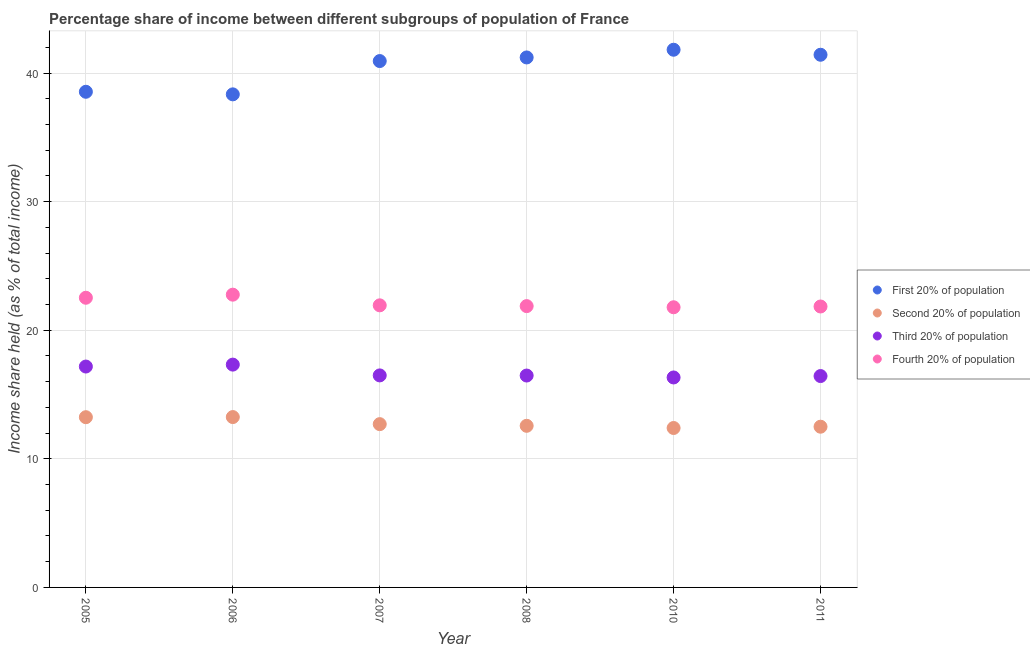What is the share of the income held by fourth 20% of the population in 2010?
Ensure brevity in your answer.  21.79. Across all years, what is the maximum share of the income held by third 20% of the population?
Offer a very short reply. 17.33. Across all years, what is the minimum share of the income held by third 20% of the population?
Your response must be concise. 16.33. In which year was the share of the income held by third 20% of the population maximum?
Your answer should be compact. 2006. In which year was the share of the income held by first 20% of the population minimum?
Keep it short and to the point. 2006. What is the total share of the income held by fourth 20% of the population in the graph?
Give a very brief answer. 132.76. What is the difference between the share of the income held by first 20% of the population in 2010 and that in 2011?
Make the answer very short. 0.39. What is the difference between the share of the income held by first 20% of the population in 2006 and the share of the income held by second 20% of the population in 2008?
Offer a terse response. 25.78. What is the average share of the income held by fourth 20% of the population per year?
Your answer should be compact. 22.13. In the year 2005, what is the difference between the share of the income held by second 20% of the population and share of the income held by fourth 20% of the population?
Your answer should be compact. -9.29. In how many years, is the share of the income held by third 20% of the population greater than 28 %?
Your answer should be very brief. 0. What is the ratio of the share of the income held by fourth 20% of the population in 2005 to that in 2006?
Your response must be concise. 0.99. Is the difference between the share of the income held by first 20% of the population in 2010 and 2011 greater than the difference between the share of the income held by fourth 20% of the population in 2010 and 2011?
Provide a short and direct response. Yes. What is the difference between the highest and the second highest share of the income held by first 20% of the population?
Offer a very short reply. 0.39. What is the difference between the highest and the lowest share of the income held by third 20% of the population?
Ensure brevity in your answer.  1. In how many years, is the share of the income held by third 20% of the population greater than the average share of the income held by third 20% of the population taken over all years?
Ensure brevity in your answer.  2. Is it the case that in every year, the sum of the share of the income held by third 20% of the population and share of the income held by second 20% of the population is greater than the sum of share of the income held by first 20% of the population and share of the income held by fourth 20% of the population?
Make the answer very short. No. Does the share of the income held by second 20% of the population monotonically increase over the years?
Make the answer very short. No. Is the share of the income held by second 20% of the population strictly less than the share of the income held by third 20% of the population over the years?
Make the answer very short. Yes. How many dotlines are there?
Offer a very short reply. 4. How many years are there in the graph?
Provide a short and direct response. 6. Does the graph contain grids?
Offer a very short reply. Yes. How many legend labels are there?
Provide a short and direct response. 4. How are the legend labels stacked?
Your answer should be compact. Vertical. What is the title of the graph?
Provide a succinct answer. Percentage share of income between different subgroups of population of France. What is the label or title of the X-axis?
Ensure brevity in your answer.  Year. What is the label or title of the Y-axis?
Make the answer very short. Income share held (as % of total income). What is the Income share held (as % of total income) in First 20% of population in 2005?
Offer a terse response. 38.55. What is the Income share held (as % of total income) in Second 20% of population in 2005?
Offer a terse response. 13.24. What is the Income share held (as % of total income) of Third 20% of population in 2005?
Your response must be concise. 17.18. What is the Income share held (as % of total income) in Fourth 20% of population in 2005?
Your answer should be very brief. 22.53. What is the Income share held (as % of total income) of First 20% of population in 2006?
Provide a succinct answer. 38.35. What is the Income share held (as % of total income) in Second 20% of population in 2006?
Offer a terse response. 13.25. What is the Income share held (as % of total income) in Third 20% of population in 2006?
Make the answer very short. 17.33. What is the Income share held (as % of total income) of Fourth 20% of population in 2006?
Provide a short and direct response. 22.77. What is the Income share held (as % of total income) in First 20% of population in 2007?
Make the answer very short. 40.94. What is the Income share held (as % of total income) in Third 20% of population in 2007?
Make the answer very short. 16.49. What is the Income share held (as % of total income) of Fourth 20% of population in 2007?
Your answer should be very brief. 21.94. What is the Income share held (as % of total income) of First 20% of population in 2008?
Provide a succinct answer. 41.22. What is the Income share held (as % of total income) in Second 20% of population in 2008?
Your response must be concise. 12.57. What is the Income share held (as % of total income) in Third 20% of population in 2008?
Your answer should be very brief. 16.48. What is the Income share held (as % of total income) in Fourth 20% of population in 2008?
Your response must be concise. 21.88. What is the Income share held (as % of total income) of First 20% of population in 2010?
Offer a very short reply. 41.82. What is the Income share held (as % of total income) of Second 20% of population in 2010?
Make the answer very short. 12.4. What is the Income share held (as % of total income) of Third 20% of population in 2010?
Make the answer very short. 16.33. What is the Income share held (as % of total income) in Fourth 20% of population in 2010?
Keep it short and to the point. 21.79. What is the Income share held (as % of total income) of First 20% of population in 2011?
Your answer should be very brief. 41.43. What is the Income share held (as % of total income) in Second 20% of population in 2011?
Provide a succinct answer. 12.5. What is the Income share held (as % of total income) in Third 20% of population in 2011?
Your answer should be compact. 16.44. What is the Income share held (as % of total income) in Fourth 20% of population in 2011?
Offer a very short reply. 21.85. Across all years, what is the maximum Income share held (as % of total income) in First 20% of population?
Ensure brevity in your answer.  41.82. Across all years, what is the maximum Income share held (as % of total income) of Second 20% of population?
Your answer should be very brief. 13.25. Across all years, what is the maximum Income share held (as % of total income) of Third 20% of population?
Ensure brevity in your answer.  17.33. Across all years, what is the maximum Income share held (as % of total income) in Fourth 20% of population?
Your answer should be compact. 22.77. Across all years, what is the minimum Income share held (as % of total income) of First 20% of population?
Your response must be concise. 38.35. Across all years, what is the minimum Income share held (as % of total income) in Second 20% of population?
Your response must be concise. 12.4. Across all years, what is the minimum Income share held (as % of total income) of Third 20% of population?
Provide a short and direct response. 16.33. Across all years, what is the minimum Income share held (as % of total income) in Fourth 20% of population?
Your answer should be very brief. 21.79. What is the total Income share held (as % of total income) in First 20% of population in the graph?
Your answer should be compact. 242.31. What is the total Income share held (as % of total income) in Second 20% of population in the graph?
Your answer should be compact. 76.66. What is the total Income share held (as % of total income) in Third 20% of population in the graph?
Keep it short and to the point. 100.25. What is the total Income share held (as % of total income) in Fourth 20% of population in the graph?
Offer a terse response. 132.76. What is the difference between the Income share held (as % of total income) in Second 20% of population in 2005 and that in 2006?
Give a very brief answer. -0.01. What is the difference between the Income share held (as % of total income) in Third 20% of population in 2005 and that in 2006?
Your answer should be very brief. -0.15. What is the difference between the Income share held (as % of total income) in Fourth 20% of population in 2005 and that in 2006?
Keep it short and to the point. -0.24. What is the difference between the Income share held (as % of total income) in First 20% of population in 2005 and that in 2007?
Make the answer very short. -2.39. What is the difference between the Income share held (as % of total income) of Second 20% of population in 2005 and that in 2007?
Your response must be concise. 0.54. What is the difference between the Income share held (as % of total income) of Third 20% of population in 2005 and that in 2007?
Keep it short and to the point. 0.69. What is the difference between the Income share held (as % of total income) in Fourth 20% of population in 2005 and that in 2007?
Your response must be concise. 0.59. What is the difference between the Income share held (as % of total income) in First 20% of population in 2005 and that in 2008?
Offer a very short reply. -2.67. What is the difference between the Income share held (as % of total income) in Second 20% of population in 2005 and that in 2008?
Provide a short and direct response. 0.67. What is the difference between the Income share held (as % of total income) of Fourth 20% of population in 2005 and that in 2008?
Make the answer very short. 0.65. What is the difference between the Income share held (as % of total income) of First 20% of population in 2005 and that in 2010?
Ensure brevity in your answer.  -3.27. What is the difference between the Income share held (as % of total income) of Second 20% of population in 2005 and that in 2010?
Give a very brief answer. 0.84. What is the difference between the Income share held (as % of total income) in Fourth 20% of population in 2005 and that in 2010?
Offer a terse response. 0.74. What is the difference between the Income share held (as % of total income) of First 20% of population in 2005 and that in 2011?
Give a very brief answer. -2.88. What is the difference between the Income share held (as % of total income) of Second 20% of population in 2005 and that in 2011?
Your answer should be very brief. 0.74. What is the difference between the Income share held (as % of total income) of Third 20% of population in 2005 and that in 2011?
Offer a very short reply. 0.74. What is the difference between the Income share held (as % of total income) of Fourth 20% of population in 2005 and that in 2011?
Keep it short and to the point. 0.68. What is the difference between the Income share held (as % of total income) of First 20% of population in 2006 and that in 2007?
Keep it short and to the point. -2.59. What is the difference between the Income share held (as % of total income) of Second 20% of population in 2006 and that in 2007?
Provide a short and direct response. 0.55. What is the difference between the Income share held (as % of total income) in Third 20% of population in 2006 and that in 2007?
Provide a short and direct response. 0.84. What is the difference between the Income share held (as % of total income) of Fourth 20% of population in 2006 and that in 2007?
Provide a succinct answer. 0.83. What is the difference between the Income share held (as % of total income) of First 20% of population in 2006 and that in 2008?
Give a very brief answer. -2.87. What is the difference between the Income share held (as % of total income) in Second 20% of population in 2006 and that in 2008?
Your answer should be compact. 0.68. What is the difference between the Income share held (as % of total income) in Third 20% of population in 2006 and that in 2008?
Offer a very short reply. 0.85. What is the difference between the Income share held (as % of total income) in Fourth 20% of population in 2006 and that in 2008?
Your response must be concise. 0.89. What is the difference between the Income share held (as % of total income) in First 20% of population in 2006 and that in 2010?
Your answer should be very brief. -3.47. What is the difference between the Income share held (as % of total income) of Second 20% of population in 2006 and that in 2010?
Ensure brevity in your answer.  0.85. What is the difference between the Income share held (as % of total income) of Fourth 20% of population in 2006 and that in 2010?
Keep it short and to the point. 0.98. What is the difference between the Income share held (as % of total income) in First 20% of population in 2006 and that in 2011?
Offer a very short reply. -3.08. What is the difference between the Income share held (as % of total income) of Second 20% of population in 2006 and that in 2011?
Offer a very short reply. 0.75. What is the difference between the Income share held (as % of total income) of Third 20% of population in 2006 and that in 2011?
Your answer should be compact. 0.89. What is the difference between the Income share held (as % of total income) of First 20% of population in 2007 and that in 2008?
Ensure brevity in your answer.  -0.28. What is the difference between the Income share held (as % of total income) of Second 20% of population in 2007 and that in 2008?
Give a very brief answer. 0.13. What is the difference between the Income share held (as % of total income) in Fourth 20% of population in 2007 and that in 2008?
Make the answer very short. 0.06. What is the difference between the Income share held (as % of total income) in First 20% of population in 2007 and that in 2010?
Keep it short and to the point. -0.88. What is the difference between the Income share held (as % of total income) of Second 20% of population in 2007 and that in 2010?
Your answer should be compact. 0.3. What is the difference between the Income share held (as % of total income) in Third 20% of population in 2007 and that in 2010?
Offer a terse response. 0.16. What is the difference between the Income share held (as % of total income) in Fourth 20% of population in 2007 and that in 2010?
Offer a terse response. 0.15. What is the difference between the Income share held (as % of total income) in First 20% of population in 2007 and that in 2011?
Your answer should be compact. -0.49. What is the difference between the Income share held (as % of total income) of Fourth 20% of population in 2007 and that in 2011?
Ensure brevity in your answer.  0.09. What is the difference between the Income share held (as % of total income) of Second 20% of population in 2008 and that in 2010?
Make the answer very short. 0.17. What is the difference between the Income share held (as % of total income) in Fourth 20% of population in 2008 and that in 2010?
Your answer should be compact. 0.09. What is the difference between the Income share held (as % of total income) of First 20% of population in 2008 and that in 2011?
Your answer should be compact. -0.21. What is the difference between the Income share held (as % of total income) in Second 20% of population in 2008 and that in 2011?
Your answer should be very brief. 0.07. What is the difference between the Income share held (as % of total income) of Third 20% of population in 2008 and that in 2011?
Your answer should be very brief. 0.04. What is the difference between the Income share held (as % of total income) of Fourth 20% of population in 2008 and that in 2011?
Offer a terse response. 0.03. What is the difference between the Income share held (as % of total income) in First 20% of population in 2010 and that in 2011?
Your response must be concise. 0.39. What is the difference between the Income share held (as % of total income) of Second 20% of population in 2010 and that in 2011?
Give a very brief answer. -0.1. What is the difference between the Income share held (as % of total income) in Third 20% of population in 2010 and that in 2011?
Your response must be concise. -0.11. What is the difference between the Income share held (as % of total income) of Fourth 20% of population in 2010 and that in 2011?
Provide a succinct answer. -0.06. What is the difference between the Income share held (as % of total income) of First 20% of population in 2005 and the Income share held (as % of total income) of Second 20% of population in 2006?
Provide a succinct answer. 25.3. What is the difference between the Income share held (as % of total income) of First 20% of population in 2005 and the Income share held (as % of total income) of Third 20% of population in 2006?
Keep it short and to the point. 21.22. What is the difference between the Income share held (as % of total income) of First 20% of population in 2005 and the Income share held (as % of total income) of Fourth 20% of population in 2006?
Your answer should be very brief. 15.78. What is the difference between the Income share held (as % of total income) of Second 20% of population in 2005 and the Income share held (as % of total income) of Third 20% of population in 2006?
Offer a terse response. -4.09. What is the difference between the Income share held (as % of total income) of Second 20% of population in 2005 and the Income share held (as % of total income) of Fourth 20% of population in 2006?
Offer a terse response. -9.53. What is the difference between the Income share held (as % of total income) in Third 20% of population in 2005 and the Income share held (as % of total income) in Fourth 20% of population in 2006?
Provide a succinct answer. -5.59. What is the difference between the Income share held (as % of total income) of First 20% of population in 2005 and the Income share held (as % of total income) of Second 20% of population in 2007?
Keep it short and to the point. 25.85. What is the difference between the Income share held (as % of total income) of First 20% of population in 2005 and the Income share held (as % of total income) of Third 20% of population in 2007?
Provide a short and direct response. 22.06. What is the difference between the Income share held (as % of total income) in First 20% of population in 2005 and the Income share held (as % of total income) in Fourth 20% of population in 2007?
Provide a short and direct response. 16.61. What is the difference between the Income share held (as % of total income) of Second 20% of population in 2005 and the Income share held (as % of total income) of Third 20% of population in 2007?
Make the answer very short. -3.25. What is the difference between the Income share held (as % of total income) in Second 20% of population in 2005 and the Income share held (as % of total income) in Fourth 20% of population in 2007?
Offer a terse response. -8.7. What is the difference between the Income share held (as % of total income) of Third 20% of population in 2005 and the Income share held (as % of total income) of Fourth 20% of population in 2007?
Offer a terse response. -4.76. What is the difference between the Income share held (as % of total income) in First 20% of population in 2005 and the Income share held (as % of total income) in Second 20% of population in 2008?
Provide a short and direct response. 25.98. What is the difference between the Income share held (as % of total income) of First 20% of population in 2005 and the Income share held (as % of total income) of Third 20% of population in 2008?
Make the answer very short. 22.07. What is the difference between the Income share held (as % of total income) of First 20% of population in 2005 and the Income share held (as % of total income) of Fourth 20% of population in 2008?
Your response must be concise. 16.67. What is the difference between the Income share held (as % of total income) in Second 20% of population in 2005 and the Income share held (as % of total income) in Third 20% of population in 2008?
Your answer should be very brief. -3.24. What is the difference between the Income share held (as % of total income) of Second 20% of population in 2005 and the Income share held (as % of total income) of Fourth 20% of population in 2008?
Keep it short and to the point. -8.64. What is the difference between the Income share held (as % of total income) of First 20% of population in 2005 and the Income share held (as % of total income) of Second 20% of population in 2010?
Offer a terse response. 26.15. What is the difference between the Income share held (as % of total income) in First 20% of population in 2005 and the Income share held (as % of total income) in Third 20% of population in 2010?
Offer a terse response. 22.22. What is the difference between the Income share held (as % of total income) in First 20% of population in 2005 and the Income share held (as % of total income) in Fourth 20% of population in 2010?
Ensure brevity in your answer.  16.76. What is the difference between the Income share held (as % of total income) of Second 20% of population in 2005 and the Income share held (as % of total income) of Third 20% of population in 2010?
Make the answer very short. -3.09. What is the difference between the Income share held (as % of total income) in Second 20% of population in 2005 and the Income share held (as % of total income) in Fourth 20% of population in 2010?
Provide a short and direct response. -8.55. What is the difference between the Income share held (as % of total income) of Third 20% of population in 2005 and the Income share held (as % of total income) of Fourth 20% of population in 2010?
Your answer should be compact. -4.61. What is the difference between the Income share held (as % of total income) of First 20% of population in 2005 and the Income share held (as % of total income) of Second 20% of population in 2011?
Your response must be concise. 26.05. What is the difference between the Income share held (as % of total income) in First 20% of population in 2005 and the Income share held (as % of total income) in Third 20% of population in 2011?
Provide a succinct answer. 22.11. What is the difference between the Income share held (as % of total income) in First 20% of population in 2005 and the Income share held (as % of total income) in Fourth 20% of population in 2011?
Offer a very short reply. 16.7. What is the difference between the Income share held (as % of total income) in Second 20% of population in 2005 and the Income share held (as % of total income) in Fourth 20% of population in 2011?
Your response must be concise. -8.61. What is the difference between the Income share held (as % of total income) in Third 20% of population in 2005 and the Income share held (as % of total income) in Fourth 20% of population in 2011?
Give a very brief answer. -4.67. What is the difference between the Income share held (as % of total income) in First 20% of population in 2006 and the Income share held (as % of total income) in Second 20% of population in 2007?
Your answer should be compact. 25.65. What is the difference between the Income share held (as % of total income) in First 20% of population in 2006 and the Income share held (as % of total income) in Third 20% of population in 2007?
Provide a short and direct response. 21.86. What is the difference between the Income share held (as % of total income) of First 20% of population in 2006 and the Income share held (as % of total income) of Fourth 20% of population in 2007?
Your answer should be compact. 16.41. What is the difference between the Income share held (as % of total income) of Second 20% of population in 2006 and the Income share held (as % of total income) of Third 20% of population in 2007?
Keep it short and to the point. -3.24. What is the difference between the Income share held (as % of total income) in Second 20% of population in 2006 and the Income share held (as % of total income) in Fourth 20% of population in 2007?
Keep it short and to the point. -8.69. What is the difference between the Income share held (as % of total income) of Third 20% of population in 2006 and the Income share held (as % of total income) of Fourth 20% of population in 2007?
Offer a terse response. -4.61. What is the difference between the Income share held (as % of total income) in First 20% of population in 2006 and the Income share held (as % of total income) in Second 20% of population in 2008?
Ensure brevity in your answer.  25.78. What is the difference between the Income share held (as % of total income) of First 20% of population in 2006 and the Income share held (as % of total income) of Third 20% of population in 2008?
Your answer should be compact. 21.87. What is the difference between the Income share held (as % of total income) of First 20% of population in 2006 and the Income share held (as % of total income) of Fourth 20% of population in 2008?
Your response must be concise. 16.47. What is the difference between the Income share held (as % of total income) of Second 20% of population in 2006 and the Income share held (as % of total income) of Third 20% of population in 2008?
Offer a terse response. -3.23. What is the difference between the Income share held (as % of total income) of Second 20% of population in 2006 and the Income share held (as % of total income) of Fourth 20% of population in 2008?
Keep it short and to the point. -8.63. What is the difference between the Income share held (as % of total income) of Third 20% of population in 2006 and the Income share held (as % of total income) of Fourth 20% of population in 2008?
Make the answer very short. -4.55. What is the difference between the Income share held (as % of total income) in First 20% of population in 2006 and the Income share held (as % of total income) in Second 20% of population in 2010?
Your answer should be very brief. 25.95. What is the difference between the Income share held (as % of total income) of First 20% of population in 2006 and the Income share held (as % of total income) of Third 20% of population in 2010?
Provide a succinct answer. 22.02. What is the difference between the Income share held (as % of total income) of First 20% of population in 2006 and the Income share held (as % of total income) of Fourth 20% of population in 2010?
Provide a succinct answer. 16.56. What is the difference between the Income share held (as % of total income) of Second 20% of population in 2006 and the Income share held (as % of total income) of Third 20% of population in 2010?
Provide a short and direct response. -3.08. What is the difference between the Income share held (as % of total income) in Second 20% of population in 2006 and the Income share held (as % of total income) in Fourth 20% of population in 2010?
Your answer should be very brief. -8.54. What is the difference between the Income share held (as % of total income) in Third 20% of population in 2006 and the Income share held (as % of total income) in Fourth 20% of population in 2010?
Offer a very short reply. -4.46. What is the difference between the Income share held (as % of total income) of First 20% of population in 2006 and the Income share held (as % of total income) of Second 20% of population in 2011?
Provide a succinct answer. 25.85. What is the difference between the Income share held (as % of total income) of First 20% of population in 2006 and the Income share held (as % of total income) of Third 20% of population in 2011?
Offer a terse response. 21.91. What is the difference between the Income share held (as % of total income) in First 20% of population in 2006 and the Income share held (as % of total income) in Fourth 20% of population in 2011?
Your answer should be very brief. 16.5. What is the difference between the Income share held (as % of total income) in Second 20% of population in 2006 and the Income share held (as % of total income) in Third 20% of population in 2011?
Make the answer very short. -3.19. What is the difference between the Income share held (as % of total income) in Third 20% of population in 2006 and the Income share held (as % of total income) in Fourth 20% of population in 2011?
Offer a very short reply. -4.52. What is the difference between the Income share held (as % of total income) in First 20% of population in 2007 and the Income share held (as % of total income) in Second 20% of population in 2008?
Your answer should be compact. 28.37. What is the difference between the Income share held (as % of total income) of First 20% of population in 2007 and the Income share held (as % of total income) of Third 20% of population in 2008?
Provide a succinct answer. 24.46. What is the difference between the Income share held (as % of total income) in First 20% of population in 2007 and the Income share held (as % of total income) in Fourth 20% of population in 2008?
Your answer should be very brief. 19.06. What is the difference between the Income share held (as % of total income) in Second 20% of population in 2007 and the Income share held (as % of total income) in Third 20% of population in 2008?
Keep it short and to the point. -3.78. What is the difference between the Income share held (as % of total income) of Second 20% of population in 2007 and the Income share held (as % of total income) of Fourth 20% of population in 2008?
Ensure brevity in your answer.  -9.18. What is the difference between the Income share held (as % of total income) in Third 20% of population in 2007 and the Income share held (as % of total income) in Fourth 20% of population in 2008?
Your answer should be very brief. -5.39. What is the difference between the Income share held (as % of total income) in First 20% of population in 2007 and the Income share held (as % of total income) in Second 20% of population in 2010?
Provide a succinct answer. 28.54. What is the difference between the Income share held (as % of total income) in First 20% of population in 2007 and the Income share held (as % of total income) in Third 20% of population in 2010?
Offer a very short reply. 24.61. What is the difference between the Income share held (as % of total income) in First 20% of population in 2007 and the Income share held (as % of total income) in Fourth 20% of population in 2010?
Your answer should be very brief. 19.15. What is the difference between the Income share held (as % of total income) in Second 20% of population in 2007 and the Income share held (as % of total income) in Third 20% of population in 2010?
Provide a succinct answer. -3.63. What is the difference between the Income share held (as % of total income) in Second 20% of population in 2007 and the Income share held (as % of total income) in Fourth 20% of population in 2010?
Ensure brevity in your answer.  -9.09. What is the difference between the Income share held (as % of total income) of First 20% of population in 2007 and the Income share held (as % of total income) of Second 20% of population in 2011?
Your response must be concise. 28.44. What is the difference between the Income share held (as % of total income) in First 20% of population in 2007 and the Income share held (as % of total income) in Third 20% of population in 2011?
Keep it short and to the point. 24.5. What is the difference between the Income share held (as % of total income) of First 20% of population in 2007 and the Income share held (as % of total income) of Fourth 20% of population in 2011?
Provide a succinct answer. 19.09. What is the difference between the Income share held (as % of total income) in Second 20% of population in 2007 and the Income share held (as % of total income) in Third 20% of population in 2011?
Your answer should be compact. -3.74. What is the difference between the Income share held (as % of total income) in Second 20% of population in 2007 and the Income share held (as % of total income) in Fourth 20% of population in 2011?
Offer a very short reply. -9.15. What is the difference between the Income share held (as % of total income) in Third 20% of population in 2007 and the Income share held (as % of total income) in Fourth 20% of population in 2011?
Your answer should be very brief. -5.36. What is the difference between the Income share held (as % of total income) of First 20% of population in 2008 and the Income share held (as % of total income) of Second 20% of population in 2010?
Offer a very short reply. 28.82. What is the difference between the Income share held (as % of total income) in First 20% of population in 2008 and the Income share held (as % of total income) in Third 20% of population in 2010?
Offer a terse response. 24.89. What is the difference between the Income share held (as % of total income) in First 20% of population in 2008 and the Income share held (as % of total income) in Fourth 20% of population in 2010?
Your answer should be compact. 19.43. What is the difference between the Income share held (as % of total income) in Second 20% of population in 2008 and the Income share held (as % of total income) in Third 20% of population in 2010?
Your answer should be compact. -3.76. What is the difference between the Income share held (as % of total income) of Second 20% of population in 2008 and the Income share held (as % of total income) of Fourth 20% of population in 2010?
Keep it short and to the point. -9.22. What is the difference between the Income share held (as % of total income) of Third 20% of population in 2008 and the Income share held (as % of total income) of Fourth 20% of population in 2010?
Your answer should be very brief. -5.31. What is the difference between the Income share held (as % of total income) of First 20% of population in 2008 and the Income share held (as % of total income) of Second 20% of population in 2011?
Make the answer very short. 28.72. What is the difference between the Income share held (as % of total income) in First 20% of population in 2008 and the Income share held (as % of total income) in Third 20% of population in 2011?
Your answer should be compact. 24.78. What is the difference between the Income share held (as % of total income) in First 20% of population in 2008 and the Income share held (as % of total income) in Fourth 20% of population in 2011?
Offer a very short reply. 19.37. What is the difference between the Income share held (as % of total income) in Second 20% of population in 2008 and the Income share held (as % of total income) in Third 20% of population in 2011?
Give a very brief answer. -3.87. What is the difference between the Income share held (as % of total income) in Second 20% of population in 2008 and the Income share held (as % of total income) in Fourth 20% of population in 2011?
Provide a succinct answer. -9.28. What is the difference between the Income share held (as % of total income) of Third 20% of population in 2008 and the Income share held (as % of total income) of Fourth 20% of population in 2011?
Your answer should be very brief. -5.37. What is the difference between the Income share held (as % of total income) in First 20% of population in 2010 and the Income share held (as % of total income) in Second 20% of population in 2011?
Make the answer very short. 29.32. What is the difference between the Income share held (as % of total income) of First 20% of population in 2010 and the Income share held (as % of total income) of Third 20% of population in 2011?
Ensure brevity in your answer.  25.38. What is the difference between the Income share held (as % of total income) in First 20% of population in 2010 and the Income share held (as % of total income) in Fourth 20% of population in 2011?
Give a very brief answer. 19.97. What is the difference between the Income share held (as % of total income) of Second 20% of population in 2010 and the Income share held (as % of total income) of Third 20% of population in 2011?
Offer a terse response. -4.04. What is the difference between the Income share held (as % of total income) of Second 20% of population in 2010 and the Income share held (as % of total income) of Fourth 20% of population in 2011?
Provide a short and direct response. -9.45. What is the difference between the Income share held (as % of total income) of Third 20% of population in 2010 and the Income share held (as % of total income) of Fourth 20% of population in 2011?
Give a very brief answer. -5.52. What is the average Income share held (as % of total income) in First 20% of population per year?
Provide a succinct answer. 40.38. What is the average Income share held (as % of total income) of Second 20% of population per year?
Ensure brevity in your answer.  12.78. What is the average Income share held (as % of total income) of Third 20% of population per year?
Your answer should be compact. 16.71. What is the average Income share held (as % of total income) in Fourth 20% of population per year?
Give a very brief answer. 22.13. In the year 2005, what is the difference between the Income share held (as % of total income) of First 20% of population and Income share held (as % of total income) of Second 20% of population?
Your answer should be compact. 25.31. In the year 2005, what is the difference between the Income share held (as % of total income) in First 20% of population and Income share held (as % of total income) in Third 20% of population?
Give a very brief answer. 21.37. In the year 2005, what is the difference between the Income share held (as % of total income) in First 20% of population and Income share held (as % of total income) in Fourth 20% of population?
Give a very brief answer. 16.02. In the year 2005, what is the difference between the Income share held (as % of total income) of Second 20% of population and Income share held (as % of total income) of Third 20% of population?
Your answer should be compact. -3.94. In the year 2005, what is the difference between the Income share held (as % of total income) of Second 20% of population and Income share held (as % of total income) of Fourth 20% of population?
Provide a succinct answer. -9.29. In the year 2005, what is the difference between the Income share held (as % of total income) in Third 20% of population and Income share held (as % of total income) in Fourth 20% of population?
Make the answer very short. -5.35. In the year 2006, what is the difference between the Income share held (as % of total income) of First 20% of population and Income share held (as % of total income) of Second 20% of population?
Give a very brief answer. 25.1. In the year 2006, what is the difference between the Income share held (as % of total income) in First 20% of population and Income share held (as % of total income) in Third 20% of population?
Offer a terse response. 21.02. In the year 2006, what is the difference between the Income share held (as % of total income) in First 20% of population and Income share held (as % of total income) in Fourth 20% of population?
Give a very brief answer. 15.58. In the year 2006, what is the difference between the Income share held (as % of total income) in Second 20% of population and Income share held (as % of total income) in Third 20% of population?
Keep it short and to the point. -4.08. In the year 2006, what is the difference between the Income share held (as % of total income) of Second 20% of population and Income share held (as % of total income) of Fourth 20% of population?
Your answer should be very brief. -9.52. In the year 2006, what is the difference between the Income share held (as % of total income) of Third 20% of population and Income share held (as % of total income) of Fourth 20% of population?
Your response must be concise. -5.44. In the year 2007, what is the difference between the Income share held (as % of total income) of First 20% of population and Income share held (as % of total income) of Second 20% of population?
Offer a terse response. 28.24. In the year 2007, what is the difference between the Income share held (as % of total income) of First 20% of population and Income share held (as % of total income) of Third 20% of population?
Provide a short and direct response. 24.45. In the year 2007, what is the difference between the Income share held (as % of total income) in Second 20% of population and Income share held (as % of total income) in Third 20% of population?
Offer a terse response. -3.79. In the year 2007, what is the difference between the Income share held (as % of total income) in Second 20% of population and Income share held (as % of total income) in Fourth 20% of population?
Offer a terse response. -9.24. In the year 2007, what is the difference between the Income share held (as % of total income) of Third 20% of population and Income share held (as % of total income) of Fourth 20% of population?
Offer a very short reply. -5.45. In the year 2008, what is the difference between the Income share held (as % of total income) in First 20% of population and Income share held (as % of total income) in Second 20% of population?
Offer a very short reply. 28.65. In the year 2008, what is the difference between the Income share held (as % of total income) of First 20% of population and Income share held (as % of total income) of Third 20% of population?
Keep it short and to the point. 24.74. In the year 2008, what is the difference between the Income share held (as % of total income) in First 20% of population and Income share held (as % of total income) in Fourth 20% of population?
Your answer should be compact. 19.34. In the year 2008, what is the difference between the Income share held (as % of total income) in Second 20% of population and Income share held (as % of total income) in Third 20% of population?
Make the answer very short. -3.91. In the year 2008, what is the difference between the Income share held (as % of total income) of Second 20% of population and Income share held (as % of total income) of Fourth 20% of population?
Give a very brief answer. -9.31. In the year 2008, what is the difference between the Income share held (as % of total income) of Third 20% of population and Income share held (as % of total income) of Fourth 20% of population?
Provide a succinct answer. -5.4. In the year 2010, what is the difference between the Income share held (as % of total income) in First 20% of population and Income share held (as % of total income) in Second 20% of population?
Give a very brief answer. 29.42. In the year 2010, what is the difference between the Income share held (as % of total income) in First 20% of population and Income share held (as % of total income) in Third 20% of population?
Give a very brief answer. 25.49. In the year 2010, what is the difference between the Income share held (as % of total income) in First 20% of population and Income share held (as % of total income) in Fourth 20% of population?
Offer a terse response. 20.03. In the year 2010, what is the difference between the Income share held (as % of total income) in Second 20% of population and Income share held (as % of total income) in Third 20% of population?
Give a very brief answer. -3.93. In the year 2010, what is the difference between the Income share held (as % of total income) of Second 20% of population and Income share held (as % of total income) of Fourth 20% of population?
Make the answer very short. -9.39. In the year 2010, what is the difference between the Income share held (as % of total income) of Third 20% of population and Income share held (as % of total income) of Fourth 20% of population?
Ensure brevity in your answer.  -5.46. In the year 2011, what is the difference between the Income share held (as % of total income) of First 20% of population and Income share held (as % of total income) of Second 20% of population?
Provide a succinct answer. 28.93. In the year 2011, what is the difference between the Income share held (as % of total income) in First 20% of population and Income share held (as % of total income) in Third 20% of population?
Keep it short and to the point. 24.99. In the year 2011, what is the difference between the Income share held (as % of total income) of First 20% of population and Income share held (as % of total income) of Fourth 20% of population?
Your answer should be very brief. 19.58. In the year 2011, what is the difference between the Income share held (as % of total income) in Second 20% of population and Income share held (as % of total income) in Third 20% of population?
Your response must be concise. -3.94. In the year 2011, what is the difference between the Income share held (as % of total income) of Second 20% of population and Income share held (as % of total income) of Fourth 20% of population?
Offer a terse response. -9.35. In the year 2011, what is the difference between the Income share held (as % of total income) in Third 20% of population and Income share held (as % of total income) in Fourth 20% of population?
Ensure brevity in your answer.  -5.41. What is the ratio of the Income share held (as % of total income) of First 20% of population in 2005 to that in 2006?
Your answer should be very brief. 1.01. What is the ratio of the Income share held (as % of total income) of Fourth 20% of population in 2005 to that in 2006?
Make the answer very short. 0.99. What is the ratio of the Income share held (as % of total income) in First 20% of population in 2005 to that in 2007?
Keep it short and to the point. 0.94. What is the ratio of the Income share held (as % of total income) of Second 20% of population in 2005 to that in 2007?
Make the answer very short. 1.04. What is the ratio of the Income share held (as % of total income) of Third 20% of population in 2005 to that in 2007?
Offer a very short reply. 1.04. What is the ratio of the Income share held (as % of total income) of Fourth 20% of population in 2005 to that in 2007?
Your answer should be very brief. 1.03. What is the ratio of the Income share held (as % of total income) of First 20% of population in 2005 to that in 2008?
Provide a short and direct response. 0.94. What is the ratio of the Income share held (as % of total income) of Second 20% of population in 2005 to that in 2008?
Your answer should be compact. 1.05. What is the ratio of the Income share held (as % of total income) in Third 20% of population in 2005 to that in 2008?
Provide a short and direct response. 1.04. What is the ratio of the Income share held (as % of total income) in Fourth 20% of population in 2005 to that in 2008?
Your answer should be compact. 1.03. What is the ratio of the Income share held (as % of total income) of First 20% of population in 2005 to that in 2010?
Offer a terse response. 0.92. What is the ratio of the Income share held (as % of total income) in Second 20% of population in 2005 to that in 2010?
Make the answer very short. 1.07. What is the ratio of the Income share held (as % of total income) of Third 20% of population in 2005 to that in 2010?
Give a very brief answer. 1.05. What is the ratio of the Income share held (as % of total income) in Fourth 20% of population in 2005 to that in 2010?
Give a very brief answer. 1.03. What is the ratio of the Income share held (as % of total income) of First 20% of population in 2005 to that in 2011?
Offer a terse response. 0.93. What is the ratio of the Income share held (as % of total income) in Second 20% of population in 2005 to that in 2011?
Ensure brevity in your answer.  1.06. What is the ratio of the Income share held (as % of total income) of Third 20% of population in 2005 to that in 2011?
Offer a terse response. 1.04. What is the ratio of the Income share held (as % of total income) of Fourth 20% of population in 2005 to that in 2011?
Your answer should be compact. 1.03. What is the ratio of the Income share held (as % of total income) in First 20% of population in 2006 to that in 2007?
Your answer should be very brief. 0.94. What is the ratio of the Income share held (as % of total income) of Second 20% of population in 2006 to that in 2007?
Offer a very short reply. 1.04. What is the ratio of the Income share held (as % of total income) in Third 20% of population in 2006 to that in 2007?
Make the answer very short. 1.05. What is the ratio of the Income share held (as % of total income) in Fourth 20% of population in 2006 to that in 2007?
Ensure brevity in your answer.  1.04. What is the ratio of the Income share held (as % of total income) in First 20% of population in 2006 to that in 2008?
Offer a very short reply. 0.93. What is the ratio of the Income share held (as % of total income) in Second 20% of population in 2006 to that in 2008?
Your answer should be compact. 1.05. What is the ratio of the Income share held (as % of total income) of Third 20% of population in 2006 to that in 2008?
Your answer should be very brief. 1.05. What is the ratio of the Income share held (as % of total income) of Fourth 20% of population in 2006 to that in 2008?
Give a very brief answer. 1.04. What is the ratio of the Income share held (as % of total income) in First 20% of population in 2006 to that in 2010?
Offer a very short reply. 0.92. What is the ratio of the Income share held (as % of total income) of Second 20% of population in 2006 to that in 2010?
Keep it short and to the point. 1.07. What is the ratio of the Income share held (as % of total income) in Third 20% of population in 2006 to that in 2010?
Give a very brief answer. 1.06. What is the ratio of the Income share held (as % of total income) in Fourth 20% of population in 2006 to that in 2010?
Offer a terse response. 1.04. What is the ratio of the Income share held (as % of total income) of First 20% of population in 2006 to that in 2011?
Provide a short and direct response. 0.93. What is the ratio of the Income share held (as % of total income) in Second 20% of population in 2006 to that in 2011?
Provide a succinct answer. 1.06. What is the ratio of the Income share held (as % of total income) in Third 20% of population in 2006 to that in 2011?
Keep it short and to the point. 1.05. What is the ratio of the Income share held (as % of total income) in Fourth 20% of population in 2006 to that in 2011?
Make the answer very short. 1.04. What is the ratio of the Income share held (as % of total income) of Second 20% of population in 2007 to that in 2008?
Your answer should be compact. 1.01. What is the ratio of the Income share held (as % of total income) in Third 20% of population in 2007 to that in 2008?
Give a very brief answer. 1. What is the ratio of the Income share held (as % of total income) in Second 20% of population in 2007 to that in 2010?
Provide a succinct answer. 1.02. What is the ratio of the Income share held (as % of total income) in Third 20% of population in 2007 to that in 2010?
Your response must be concise. 1.01. What is the ratio of the Income share held (as % of total income) in First 20% of population in 2007 to that in 2011?
Your answer should be compact. 0.99. What is the ratio of the Income share held (as % of total income) of Second 20% of population in 2007 to that in 2011?
Provide a short and direct response. 1.02. What is the ratio of the Income share held (as % of total income) of First 20% of population in 2008 to that in 2010?
Make the answer very short. 0.99. What is the ratio of the Income share held (as % of total income) of Second 20% of population in 2008 to that in 2010?
Your answer should be compact. 1.01. What is the ratio of the Income share held (as % of total income) in Third 20% of population in 2008 to that in 2010?
Ensure brevity in your answer.  1.01. What is the ratio of the Income share held (as % of total income) in Fourth 20% of population in 2008 to that in 2010?
Ensure brevity in your answer.  1. What is the ratio of the Income share held (as % of total income) of Second 20% of population in 2008 to that in 2011?
Provide a succinct answer. 1.01. What is the ratio of the Income share held (as % of total income) of Fourth 20% of population in 2008 to that in 2011?
Your answer should be compact. 1. What is the ratio of the Income share held (as % of total income) in First 20% of population in 2010 to that in 2011?
Ensure brevity in your answer.  1.01. What is the ratio of the Income share held (as % of total income) of Second 20% of population in 2010 to that in 2011?
Your answer should be very brief. 0.99. What is the difference between the highest and the second highest Income share held (as % of total income) in First 20% of population?
Provide a short and direct response. 0.39. What is the difference between the highest and the second highest Income share held (as % of total income) of Second 20% of population?
Keep it short and to the point. 0.01. What is the difference between the highest and the second highest Income share held (as % of total income) in Fourth 20% of population?
Your response must be concise. 0.24. What is the difference between the highest and the lowest Income share held (as % of total income) of First 20% of population?
Give a very brief answer. 3.47. What is the difference between the highest and the lowest Income share held (as % of total income) of Second 20% of population?
Keep it short and to the point. 0.85. What is the difference between the highest and the lowest Income share held (as % of total income) in Third 20% of population?
Offer a terse response. 1. What is the difference between the highest and the lowest Income share held (as % of total income) in Fourth 20% of population?
Provide a short and direct response. 0.98. 